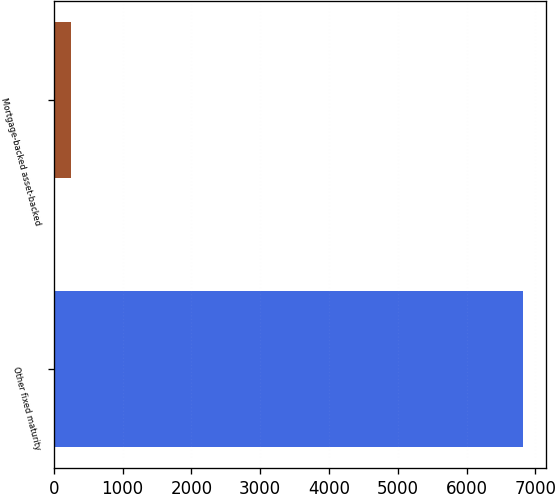Convert chart. <chart><loc_0><loc_0><loc_500><loc_500><bar_chart><fcel>Other fixed maturity<fcel>Mortgage-backed asset-backed<nl><fcel>6814<fcel>244<nl></chart> 